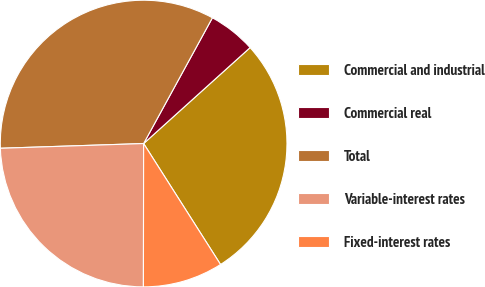<chart> <loc_0><loc_0><loc_500><loc_500><pie_chart><fcel>Commercial and industrial<fcel>Commercial real<fcel>Total<fcel>Variable-interest rates<fcel>Fixed-interest rates<nl><fcel>27.66%<fcel>5.36%<fcel>33.49%<fcel>24.45%<fcel>9.04%<nl></chart> 